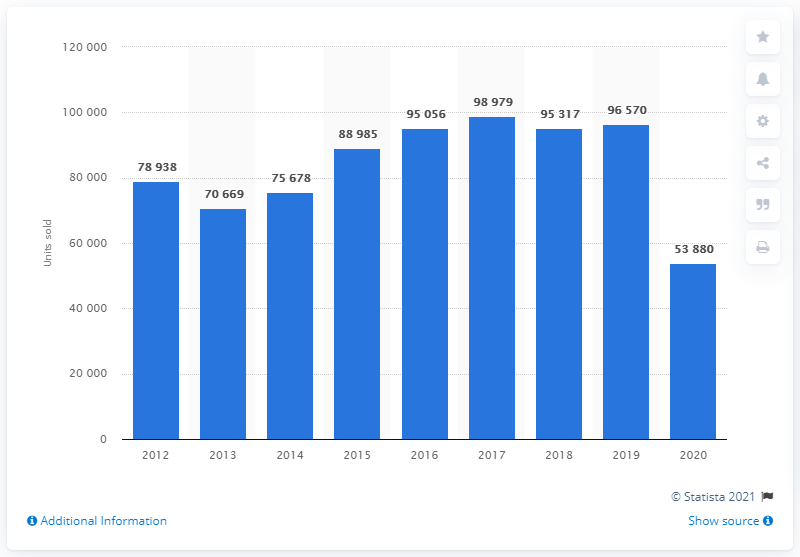Outline some significant characteristics in this image. In the year 2017, the highest number of Opel automobiles sold in the United States was 98,979. 